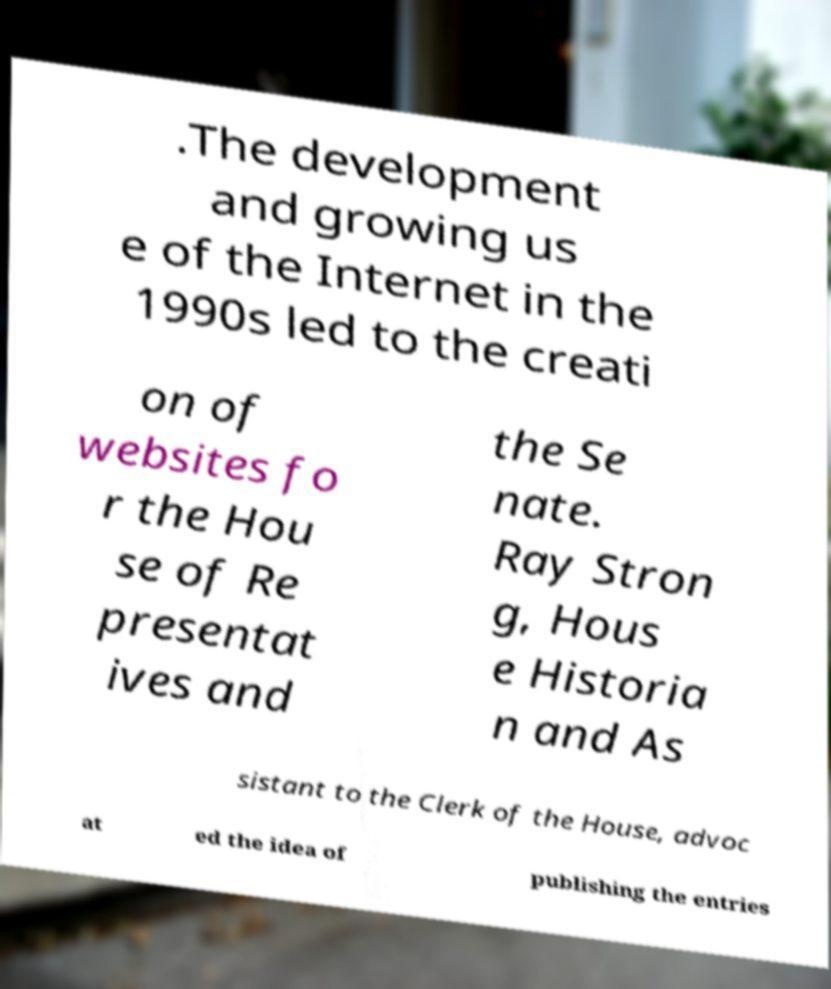There's text embedded in this image that I need extracted. Can you transcribe it verbatim? .The development and growing us e of the Internet in the 1990s led to the creati on of websites fo r the Hou se of Re presentat ives and the Se nate. Ray Stron g, Hous e Historia n and As sistant to the Clerk of the House, advoc at ed the idea of publishing the entries 